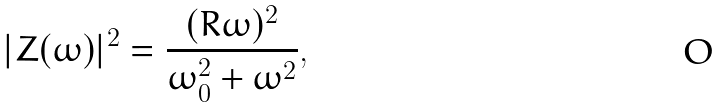<formula> <loc_0><loc_0><loc_500><loc_500>| Z ( \omega ) | ^ { 2 } = \frac { ( R \omega ) ^ { 2 } } { \omega _ { 0 } ^ { 2 } + \omega ^ { 2 } } ,</formula> 